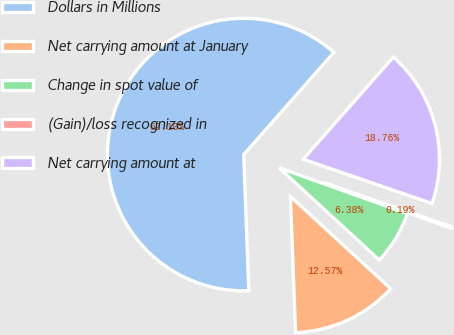Convert chart. <chart><loc_0><loc_0><loc_500><loc_500><pie_chart><fcel>Dollars in Millions<fcel>Net carrying amount at January<fcel>Change in spot value of<fcel>(Gain)/loss recognized in<fcel>Net carrying amount at<nl><fcel>62.11%<fcel>12.57%<fcel>6.38%<fcel>0.19%<fcel>18.76%<nl></chart> 